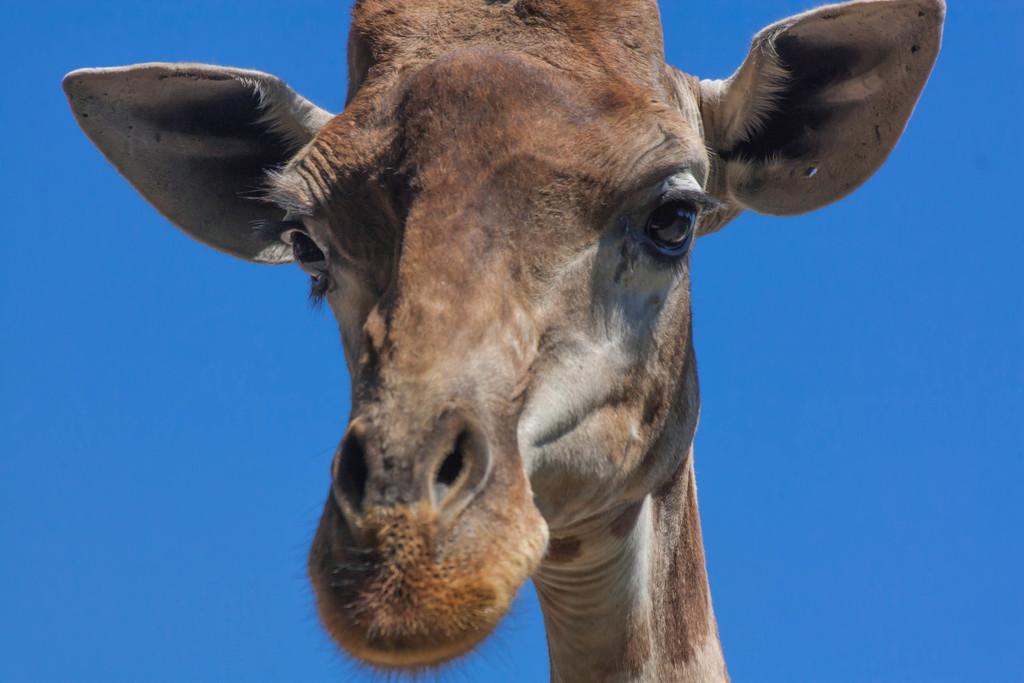What animal's face is the focus of the image? The image is a zoom-in of a giraffe's face. What can be seen in the background of the image? The sky is visible behind the giraffe. How many rings are visible on the giraffe's face in the image? There are no rings visible on the giraffe's face in the image. What type of geese can be seen flying in the sky behind the giraffe? There are no geese present in the image; only the giraffe's face and the sky are visible. 